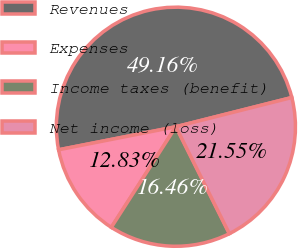Convert chart. <chart><loc_0><loc_0><loc_500><loc_500><pie_chart><fcel>Revenues<fcel>Expenses<fcel>Income taxes (benefit)<fcel>Net income (loss)<nl><fcel>49.16%<fcel>12.83%<fcel>16.46%<fcel>21.55%<nl></chart> 